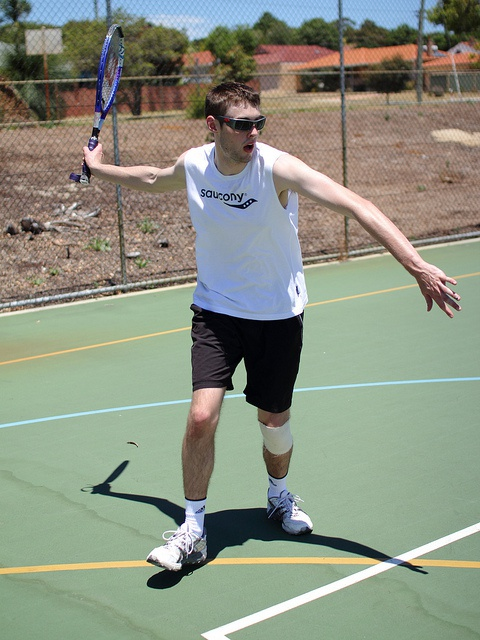Describe the objects in this image and their specific colors. I can see people in teal, darkgray, black, and gray tones and tennis racket in teal, gray, black, navy, and darkgray tones in this image. 